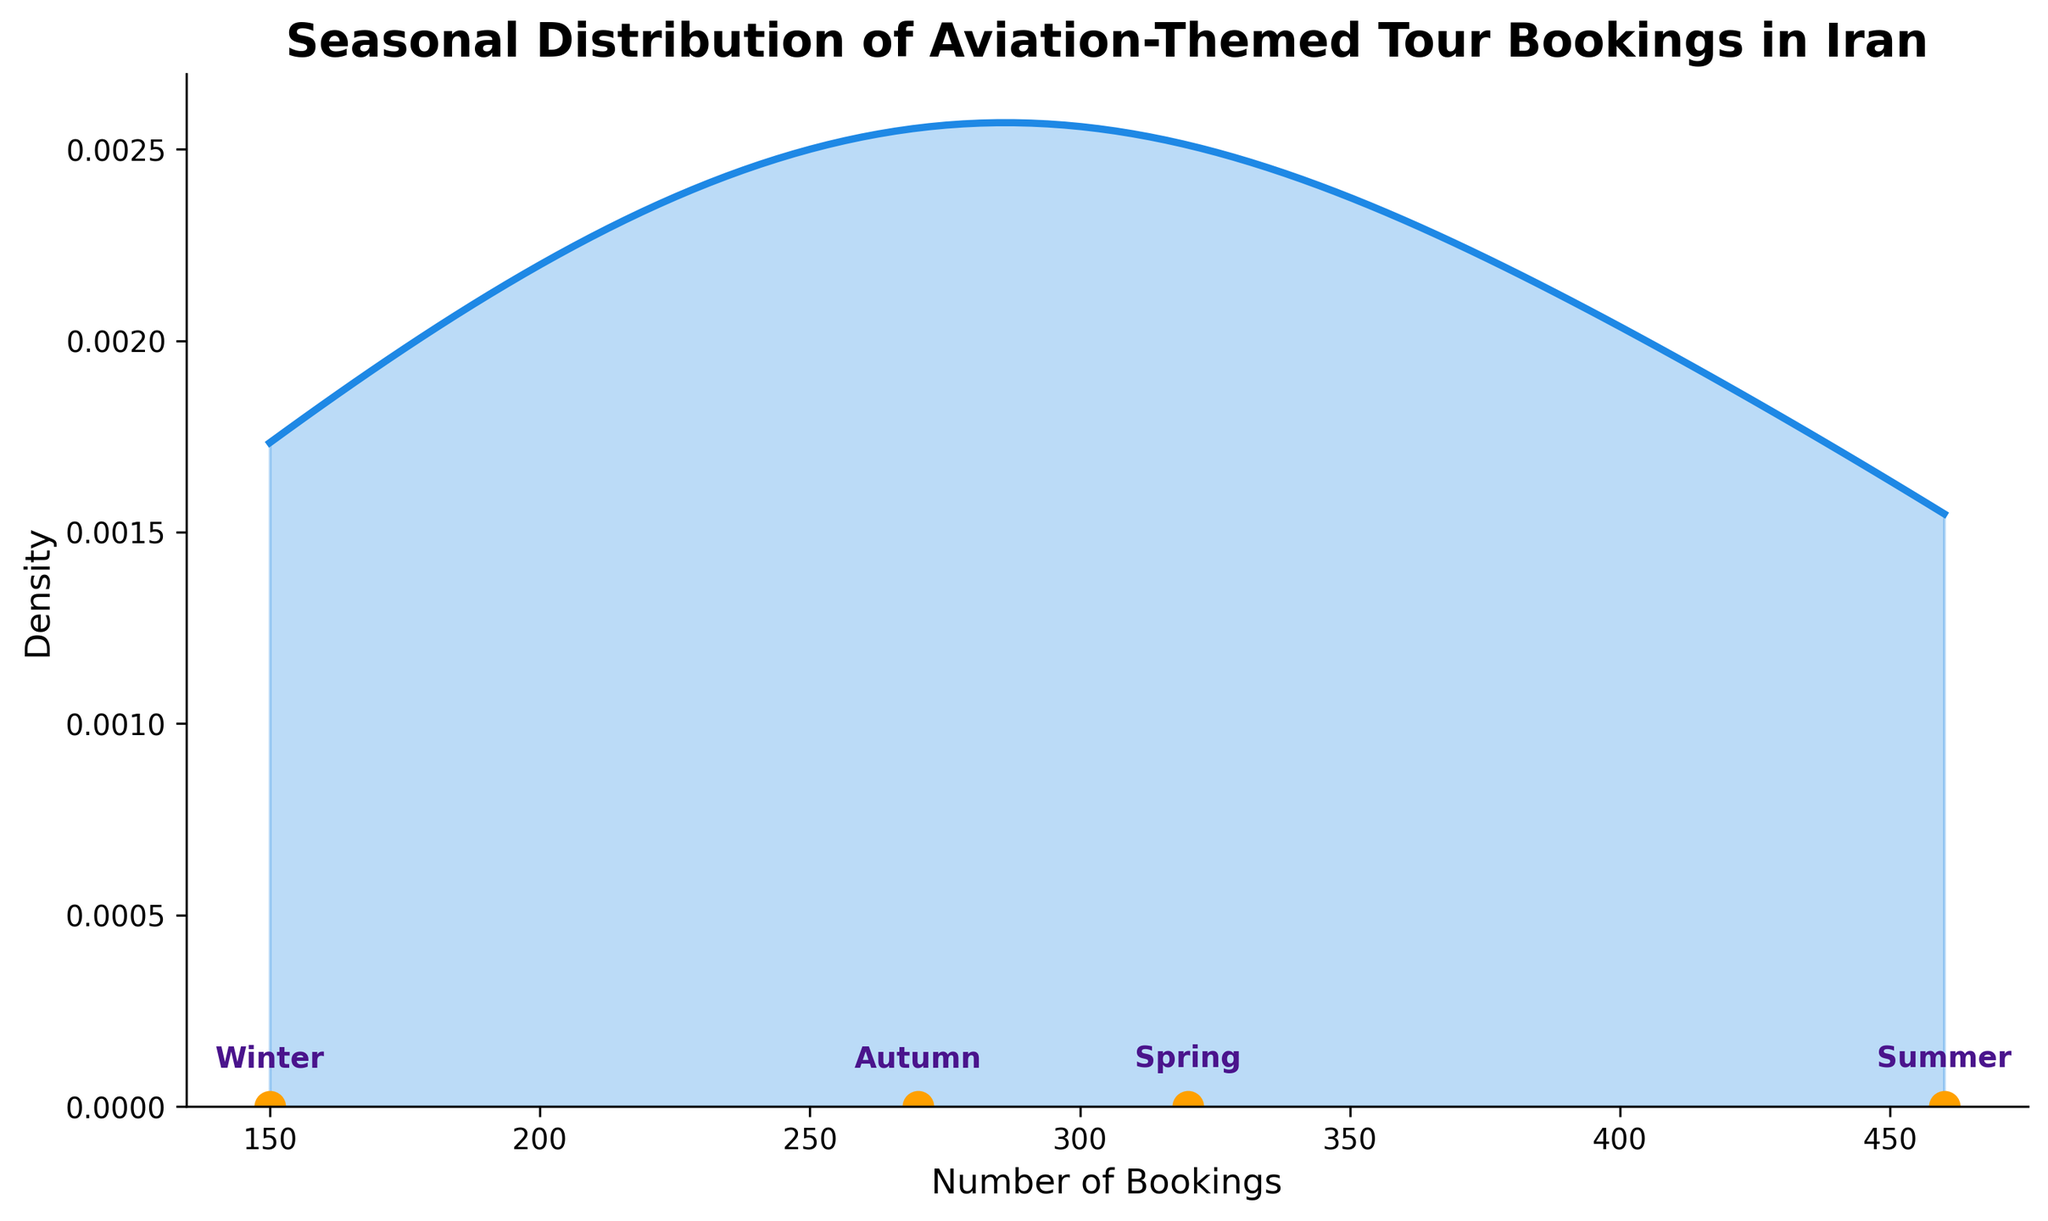what is the title of the plot? The title is displayed at the top of the plot and gives an overview of what the figure represents. It reads "Seasonal Distribution of Aviation-Themed Tour Bookings in Iran."
Answer: Seasonal Distribution of Aviation-Themed Tour Bookings in Iran How many seasons are represented in the plot? The plot shows that there are four distinct data points, each annotated with a season label. These are Winter, Spring, Summer, and Autumn.
Answer: Four Which season has the highest number of bookings? By observing the scatter plot at the bottom of the plot, the data point representing the highest number of bookings is for Summer. The label Summer is closest to the highest value on the x-axis.
Answer: Summer What's the difference in the number of bookings between Summer and Winter? The number of bookings for Summer is 460, and for Winter, it is 150. The difference is calculated as 460 - 150.
Answer: 310 What is the overall trend of the number of bookings from Winter to Autumn? Observing the scatter plot from left to right, the pattern is an increase from Winter (150) to Spring (320) to Summer (460), followed by a decrease to Autumn (270).
Answer: Increase, then decrease Are there any seasons with a number of bookings less than 200? From the scatter plot, Winter's bookings (150) are the only number that is less than 200 among the seasons represented.
Answer: Winter What's the range of the number of bookings for these seasons? The range is calculated by subtracting the smallest value (150) from the largest value (460). Hence, the range is 460 - 150.
Answer: 310 How does Spring compare to Autumn in terms of the number of bookings? Spring has 320 bookings and Autumn has 270. Comparatively, Spring has more bookings than Autumn.
Answer: Spring has more bookings than Autumn What can be inferred from the density plot about the distribution of bookings? The density plot shows a smooth curve that peaks near the higher booking numbers, indicating that more bookings occur in the higher end of the range. This suggests that seasons like Summer have a higher frequency of bookings.
Answer: Higher frequency at higher booking numbers 